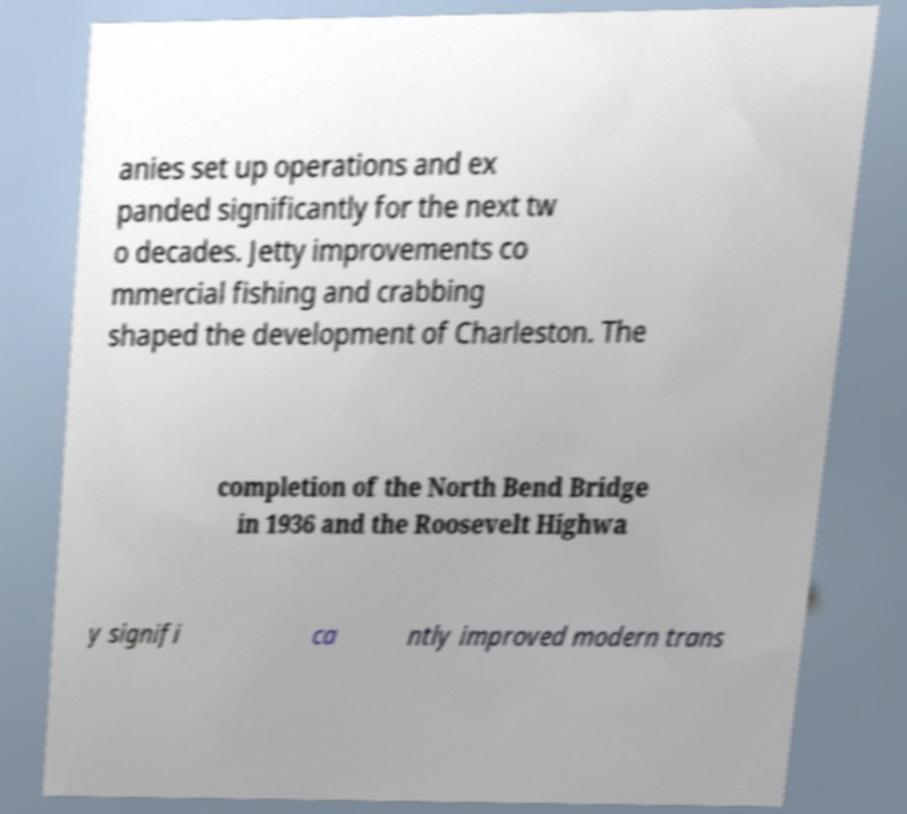Can you read and provide the text displayed in the image?This photo seems to have some interesting text. Can you extract and type it out for me? anies set up operations and ex panded significantly for the next tw o decades. Jetty improvements co mmercial fishing and crabbing shaped the development of Charleston. The completion of the North Bend Bridge in 1936 and the Roosevelt Highwa y signifi ca ntly improved modern trans 